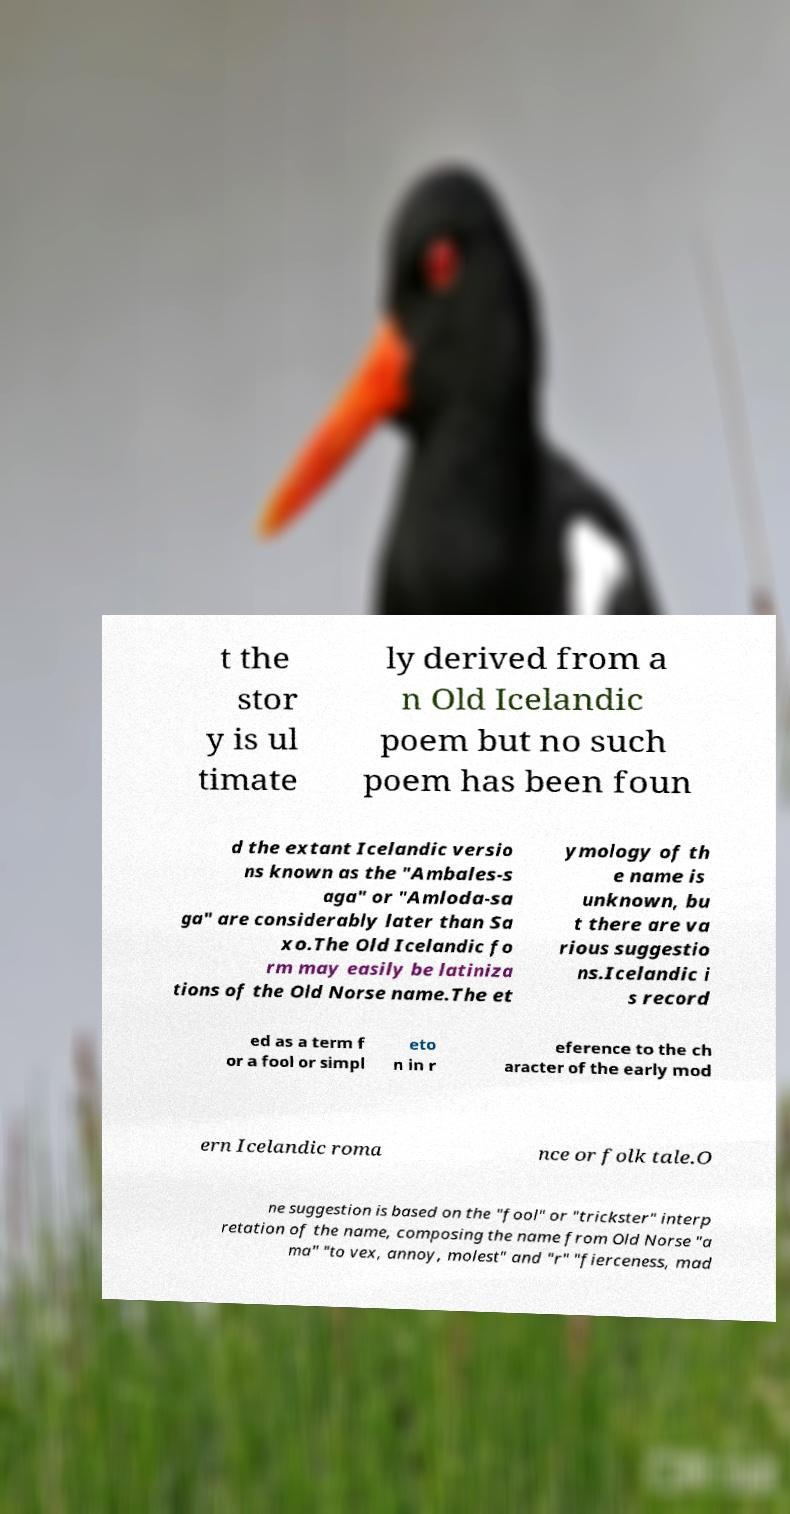Please read and relay the text visible in this image. What does it say? t the stor y is ul timate ly derived from a n Old Icelandic poem but no such poem has been foun d the extant Icelandic versio ns known as the "Ambales-s aga" or "Amloda-sa ga" are considerably later than Sa xo.The Old Icelandic fo rm may easily be latiniza tions of the Old Norse name.The et ymology of th e name is unknown, bu t there are va rious suggestio ns.Icelandic i s record ed as a term f or a fool or simpl eto n in r eference to the ch aracter of the early mod ern Icelandic roma nce or folk tale.O ne suggestion is based on the "fool" or "trickster" interp retation of the name, composing the name from Old Norse "a ma" "to vex, annoy, molest" and "r" "fierceness, mad 